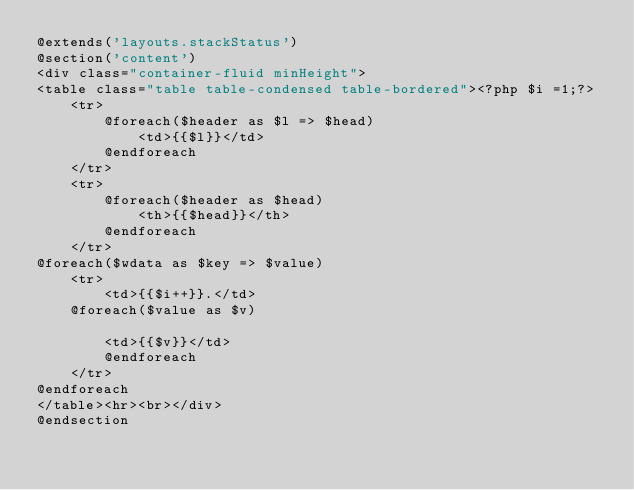Convert code to text. <code><loc_0><loc_0><loc_500><loc_500><_PHP_>@extends('layouts.stackStatus')
@section('content')
<div class="container-fluid minHeight">
<table class="table table-condensed table-bordered"><?php $i =1;?>
	<tr>
		@foreach($header as $l => $head)
			<td>{{$l}}</td>
		@endforeach
	</tr>
	<tr>
		@foreach($header as $head)
			<th>{{$head}}</th>
		@endforeach
	</tr>
@foreach($wdata as $key => $value)
	<tr>
		<td>{{$i++}}.</td>
	@foreach($value as $v)
		
		<td>{{$v}}</td>
		@endforeach
	</tr>
@endforeach
</table><hr><br></div>
@endsection</code> 